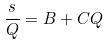<formula> <loc_0><loc_0><loc_500><loc_500>\frac { s } { Q } = B + C Q</formula> 